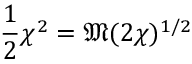<formula> <loc_0><loc_0><loc_500><loc_500>{ \frac { 1 } { 2 } } \chi ^ { 2 } = { \mathfrak { M } } ( 2 \chi ) ^ { 1 / 2 }</formula> 